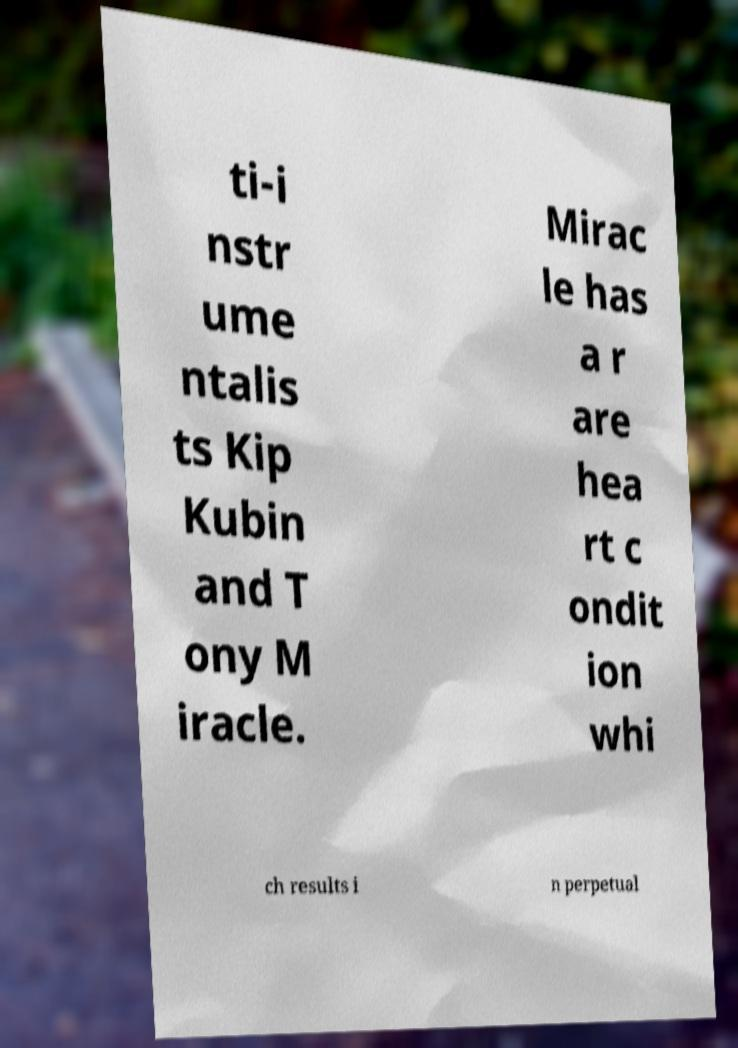Please identify and transcribe the text found in this image. ti-i nstr ume ntalis ts Kip Kubin and T ony M iracle. Mirac le has a r are hea rt c ondit ion whi ch results i n perpetual 